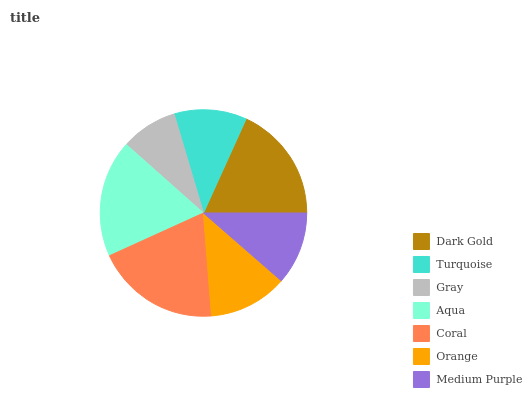Is Gray the minimum?
Answer yes or no. Yes. Is Coral the maximum?
Answer yes or no. Yes. Is Turquoise the minimum?
Answer yes or no. No. Is Turquoise the maximum?
Answer yes or no. No. Is Dark Gold greater than Turquoise?
Answer yes or no. Yes. Is Turquoise less than Dark Gold?
Answer yes or no. Yes. Is Turquoise greater than Dark Gold?
Answer yes or no. No. Is Dark Gold less than Turquoise?
Answer yes or no. No. Is Orange the high median?
Answer yes or no. Yes. Is Orange the low median?
Answer yes or no. Yes. Is Aqua the high median?
Answer yes or no. No. Is Dark Gold the low median?
Answer yes or no. No. 